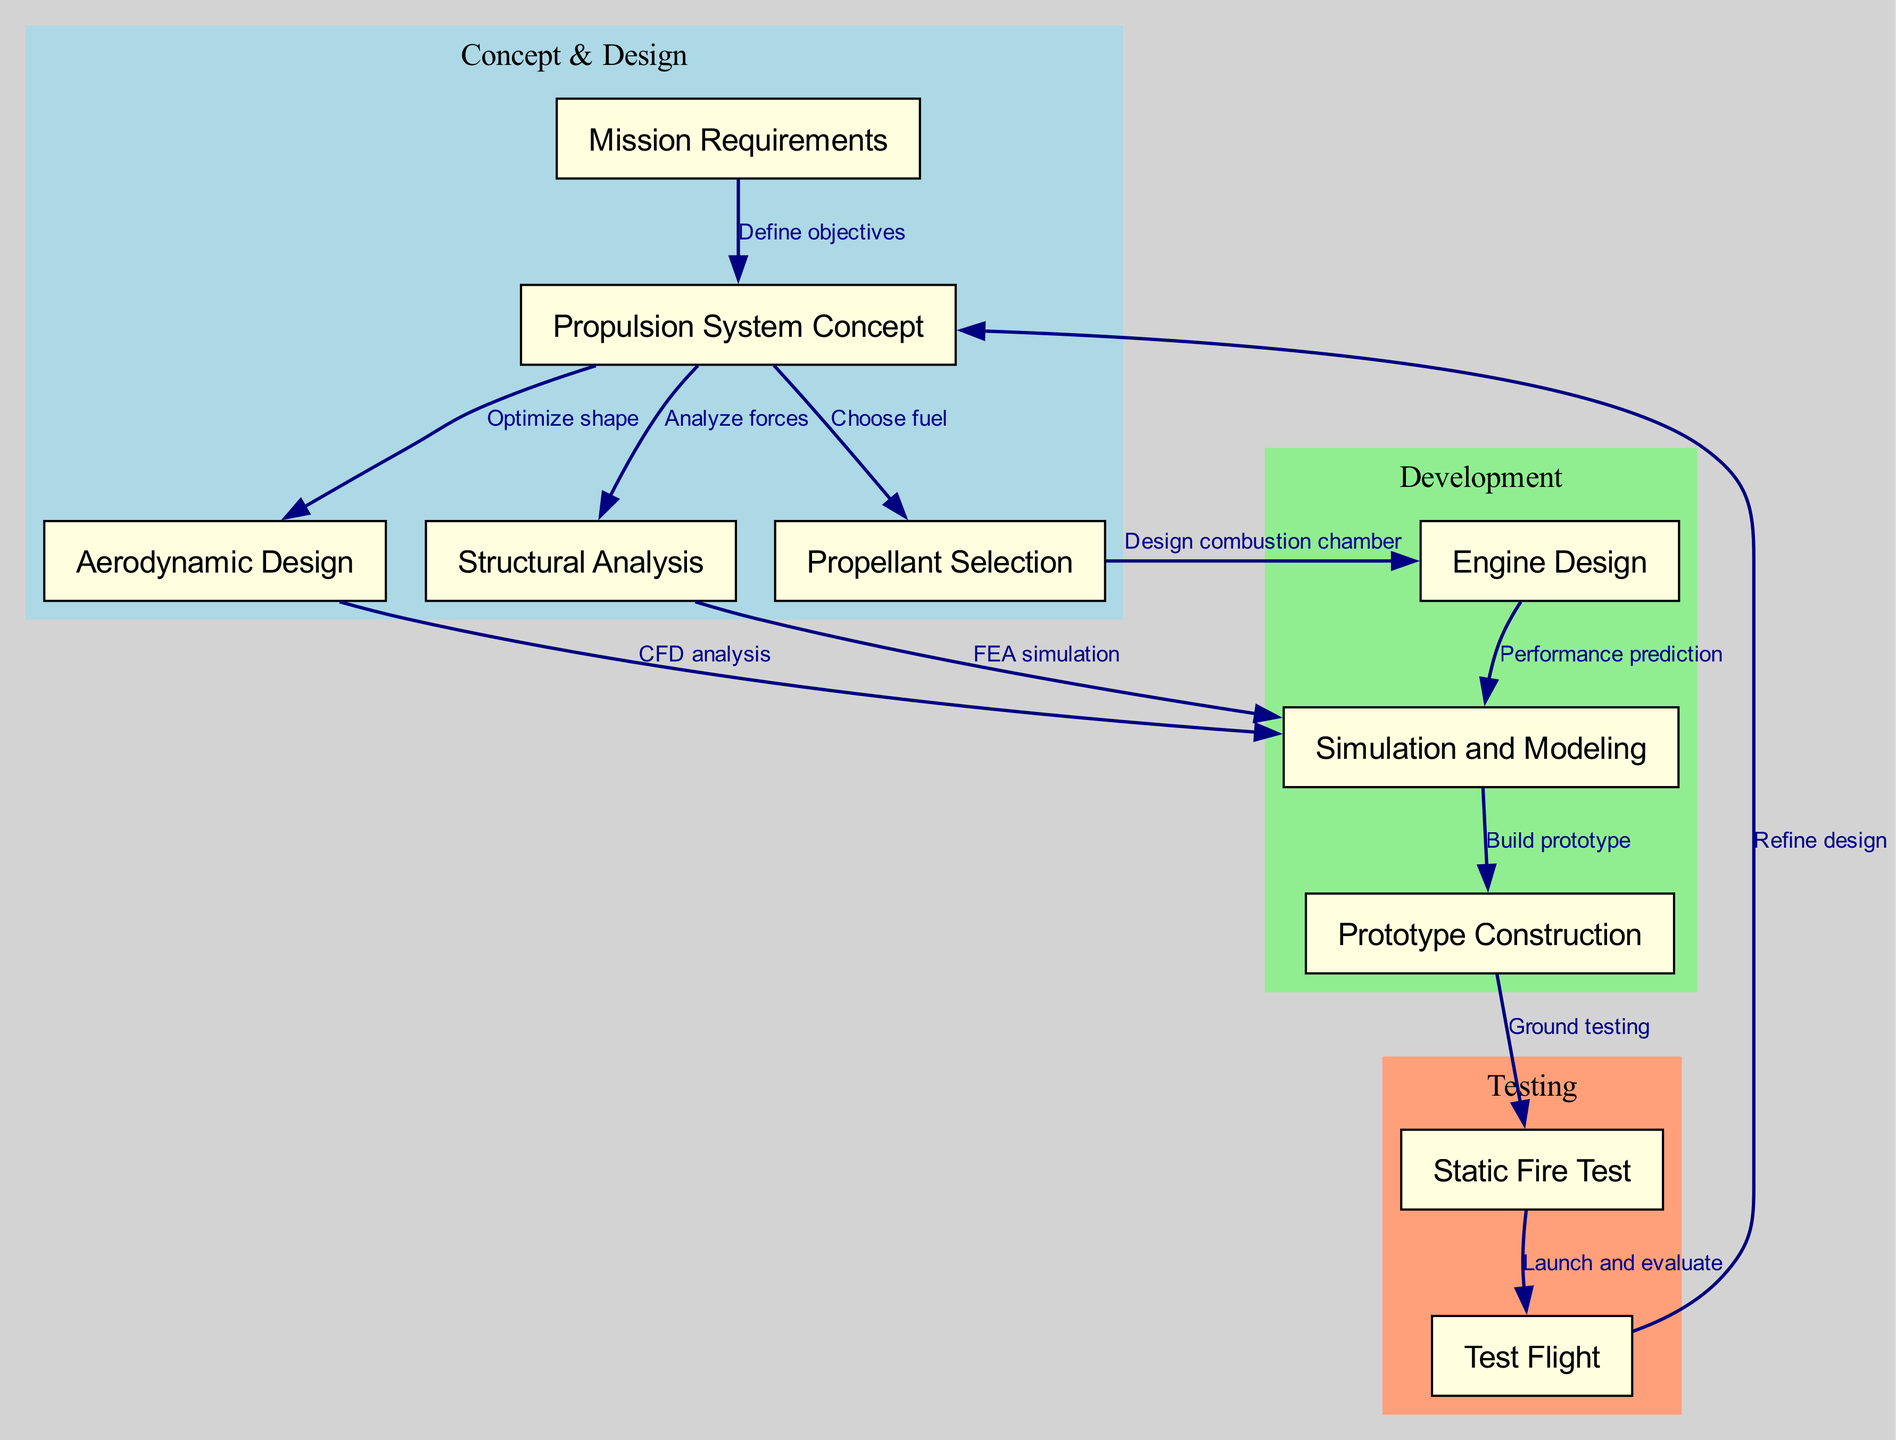What is the first node in the design process? The diagram starts with the node labeled "Mission Requirements," indicating that defining mission requirements is the initial step in the rocket design process.
Answer: Mission Requirements How many nodes are present in the diagram? By counting all the nodes listed in the diagram, there are a total of ten distinct nodes that represent various steps in the rocket design process.
Answer: 10 What is the edge between "Static Fire Test" and "Test Flight"? The edge specifies the relationship between "Static Fire Test" and "Test Flight," indicating that the procedure involves launching and evaluating the rocket after conducting a static fire test.
Answer: Launch and evaluate Which nodes are part of the 'Concept & Design' phase? The 'Concept & Design' phase includes nodes one through five, specifically: "Mission Requirements," "Propulsion System Concept," "Aerodynamic Design," "Structural Analysis," and "Propellant Selection."
Answer: Mission Requirements, Propulsion System Concept, Aerodynamic Design, Structural Analysis, Propellant Selection What decision point follows "Test Flight"? After the "Test Flight," the process includes a decision point that leads back to refining the design based on the outcomes of the flight test, indicating an iterative process.
Answer: Refine design Which node represents the stage where prototypes are built? The node labeled "Prototype Construction" indicates the stage in which prototypes are constructed, highlighting a critical step before testing.
Answer: Prototype Construction How does "Engine Design" relate to "Simulation and Modeling"? The connection between "Engine Design" and "Simulation and Modeling" indicates that the predictions about engine performance are supported by simulation and modeling processes.
Answer: Performance prediction Which edge leads to the selection of "Propellant"? The edge connecting "Propulsion System Concept" to "Propellant Selection" indicates that after defining the propulsion system concept, the next step is to choose the appropriate fuel.
Answer: Choose fuel What is the purpose of "Aerodynamic Design"? The purpose of "Aerodynamic Design" is to optimize the rocket's shape to ensure better flight performance and reduce drag, which is crucial for efficient travel through the atmosphere.
Answer: Optimize shape 